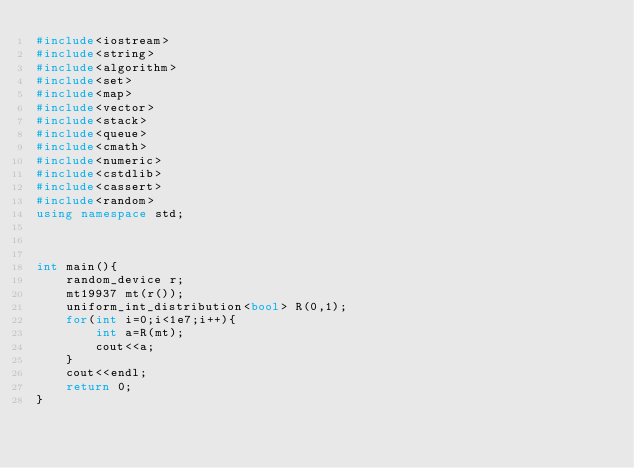Convert code to text. <code><loc_0><loc_0><loc_500><loc_500><_C++_>#include<iostream>
#include<string>
#include<algorithm>
#include<set>
#include<map>
#include<vector>
#include<stack>
#include<queue>
#include<cmath>
#include<numeric>
#include<cstdlib>
#include<cassert>
#include<random>
using namespace std;



int main(){
    random_device r;
    mt19937 mt(r());
    uniform_int_distribution<bool> R(0,1);
    for(int i=0;i<1e7;i++){
        int a=R(mt);
        cout<<a;
    }
    cout<<endl;
    return 0;
}

</code> 